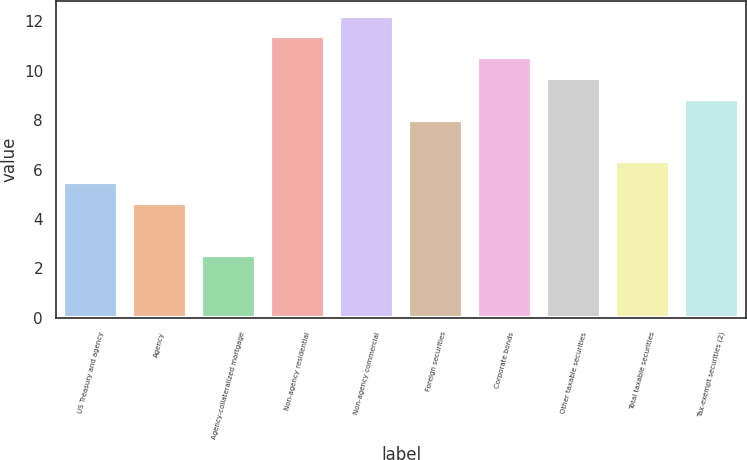Convert chart to OTSL. <chart><loc_0><loc_0><loc_500><loc_500><bar_chart><fcel>US Treasury and agency<fcel>Agency<fcel>Agency-collateralized mortgage<fcel>Non-agency residential<fcel>Non-agency commercial<fcel>Foreign securities<fcel>Corporate bonds<fcel>Other taxable securities<fcel>Total taxable securities<fcel>Tax-exempt securities (2)<nl><fcel>5.5<fcel>4.66<fcel>2.53<fcel>11.38<fcel>12.22<fcel>8.02<fcel>10.54<fcel>9.7<fcel>6.34<fcel>8.86<nl></chart> 